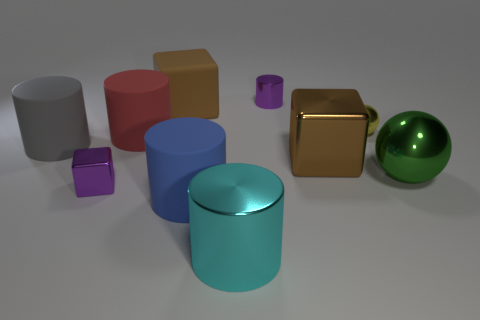Are there more large gray rubber cylinders on the left side of the big gray thing than big shiny blocks behind the green metallic thing?
Give a very brief answer. No. There is a purple object that is in front of the tiny metal thing behind the large rubber object behind the large red rubber thing; what size is it?
Your answer should be very brief. Small. Are there any small matte cylinders of the same color as the large rubber block?
Ensure brevity in your answer.  No. How many big cylinders are there?
Your answer should be very brief. 4. What material is the small purple object right of the small shiny object left of the metal cylinder in front of the large blue thing?
Keep it short and to the point. Metal. Are there any large red things that have the same material as the purple cube?
Give a very brief answer. No. Is the blue cylinder made of the same material as the cyan cylinder?
Offer a very short reply. No. How many spheres are small yellow metallic objects or big cyan things?
Offer a very short reply. 1. There is a cube that is the same material as the big blue cylinder; what color is it?
Offer a very short reply. Brown. Is the number of yellow rubber objects less than the number of red cylinders?
Keep it short and to the point. Yes. 